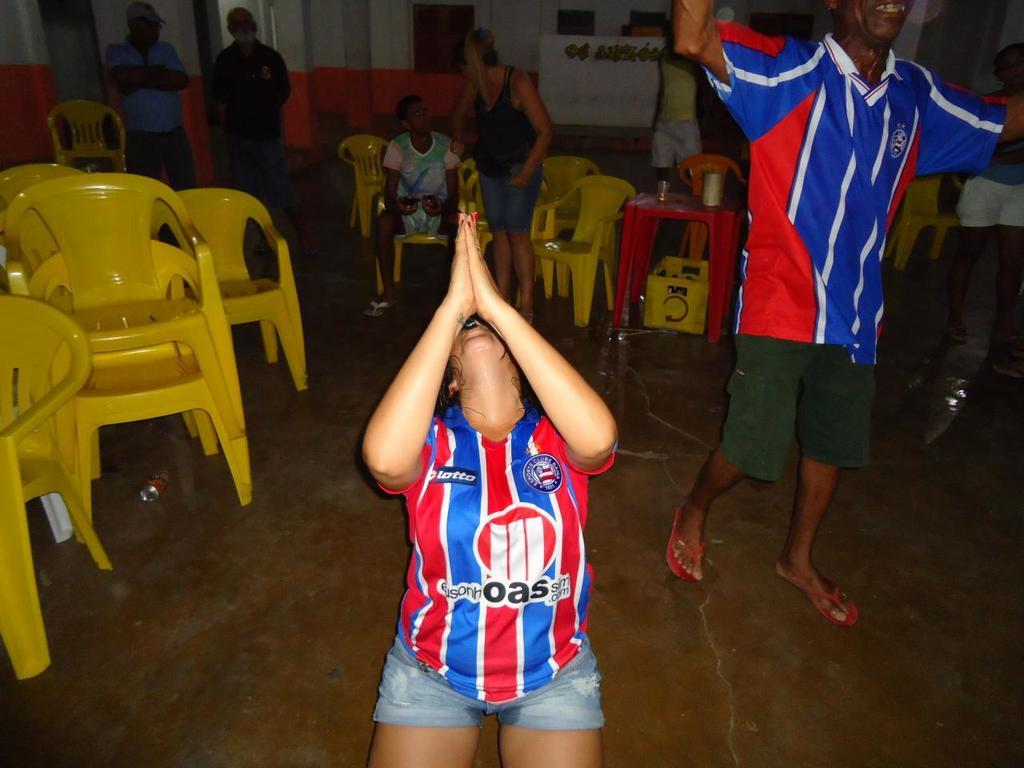<image>
Relay a brief, clear account of the picture shown. A woman wearing a jersey that says OAS on it is praying. 